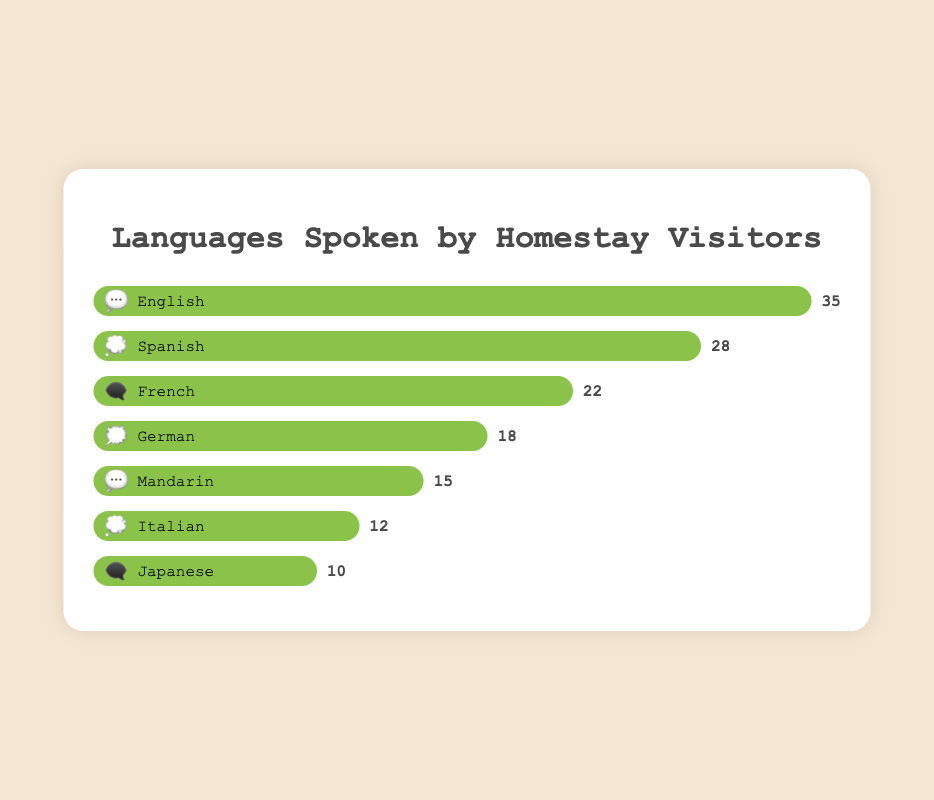What language is spoken by the most visitors? The figure has bars representing different languages. The bar with the longest fill corresponds to English, indicating it is spoken by the most visitors.
Answer: English How many visitors speak Spanish? Look for the Spanish bar and check the visitor label next to it. The label shows 28 visitors.
Answer: 28 Compare the number of visitors who speak French and German. Which is more and by how much? The French bar shows 22 visitors and the German bar shows 18 visitors. Subtracting these, French has 4 more visitors than German.
Answer: French by 4 What percentage of total visitors speak Mandarin? Add the visitor numbers: 35 (English) + 28 (Spanish) + 22 (French) + 18 (German) + 15 (Mandarin) + 12 (Italian) + 10 (Japanese) = 140 visitors in total. Mandarin has 15 visitors. Calculating the percentage: (15/140) × 100 ≈ 10.71%.
Answer: ~10.71% Which two languages have the closest number of visitors? Comparing the visitor labels easily, Italian (12) and Japanese (10) have the closest numbers, with a difference of 2.
Answer: Italian and Japanese If you combined the number of visitors speaking French and Italian, how many visitors would that be? French has 22 visitors and Italian has 12 visitors. Adding these gives 34 visitors.
Answer: 34 How many more visitors speak English compared to Japanese? The English bar shows 35 visitors while the Japanese bar shows 10 visitors. Subtracting these, English has 25 more visitors than Japanese.
Answer: 25 Which language represented by the 💭 emoji has more visitors? There are two languages with the 💭 emoji: Spanish (28 visitors) and Italian (12 visitors). Spanish has more visitors.
Answer: Spanish Identify all languages with 15 or more visitors. Referring to the visitor labels, English (35), Spanish (28), French (22), German (18), and Mandarin (15) all have 15 or more visitors.
Answer: English, Spanish, French, German, Mandarin 